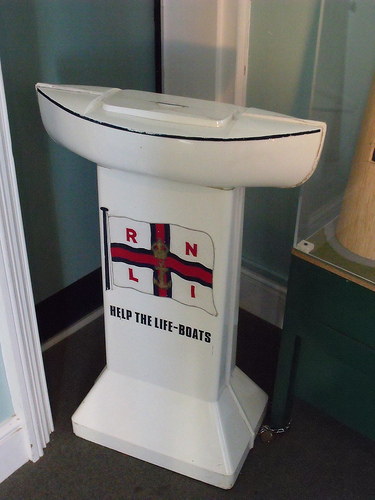<image>
Is the flag on the stand? Yes. Looking at the image, I can see the flag is positioned on top of the stand, with the stand providing support. Is there a flag on the ground? No. The flag is not positioned on the ground. They may be near each other, but the flag is not supported by or resting on top of the ground. Is the flag in the wall? No. The flag is not contained within the wall. These objects have a different spatial relationship. 